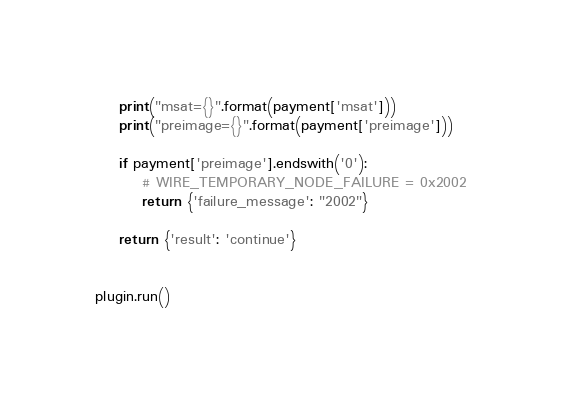<code> <loc_0><loc_0><loc_500><loc_500><_Python_>    print("msat={}".format(payment['msat']))
    print("preimage={}".format(payment['preimage']))

    if payment['preimage'].endswith('0'):
        # WIRE_TEMPORARY_NODE_FAILURE = 0x2002
        return {'failure_message': "2002"}

    return {'result': 'continue'}


plugin.run()
</code> 